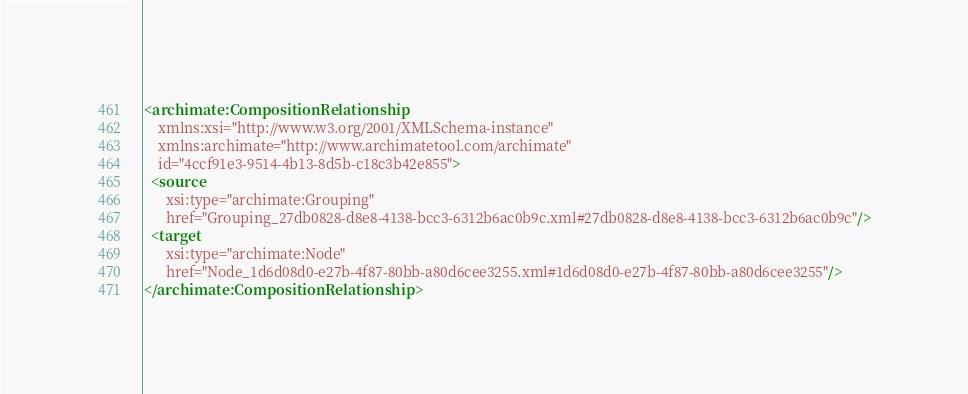Convert code to text. <code><loc_0><loc_0><loc_500><loc_500><_XML_><archimate:CompositionRelationship
    xmlns:xsi="http://www.w3.org/2001/XMLSchema-instance"
    xmlns:archimate="http://www.archimatetool.com/archimate"
    id="4ccf91e3-9514-4b13-8d5b-c18c3b42e855">
  <source
      xsi:type="archimate:Grouping"
      href="Grouping_27db0828-d8e8-4138-bcc3-6312b6ac0b9c.xml#27db0828-d8e8-4138-bcc3-6312b6ac0b9c"/>
  <target
      xsi:type="archimate:Node"
      href="Node_1d6d08d0-e27b-4f87-80bb-a80d6cee3255.xml#1d6d08d0-e27b-4f87-80bb-a80d6cee3255"/>
</archimate:CompositionRelationship>
</code> 